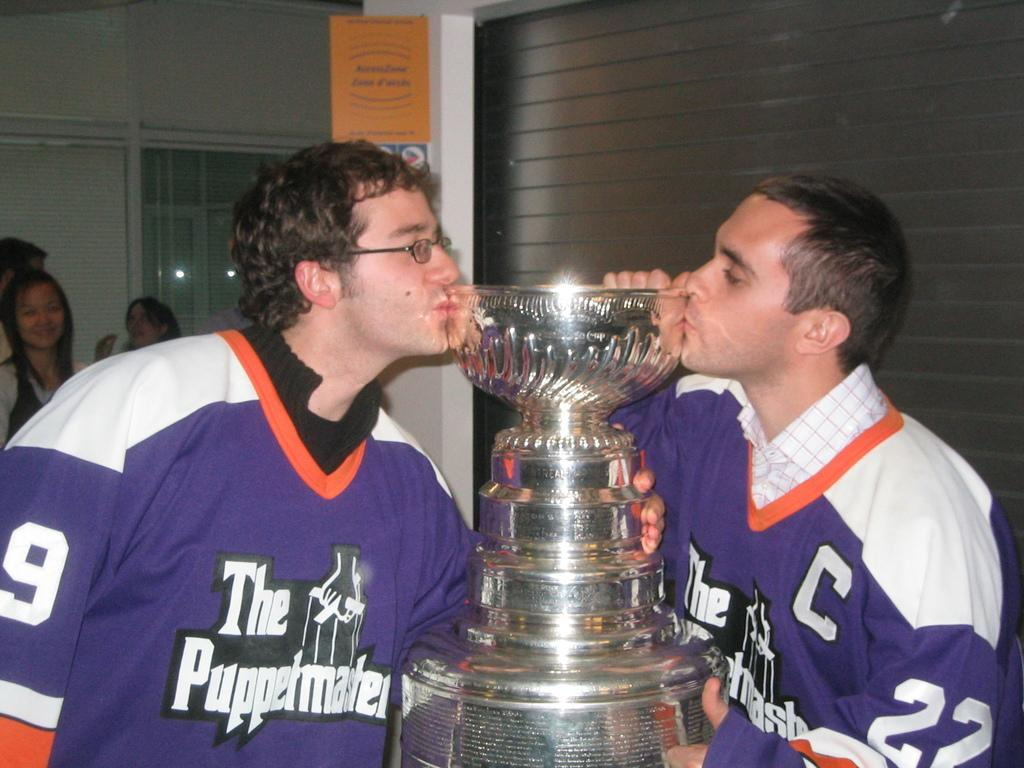<image>
Create a compact narrative representing the image presented. Two men in jerseys for the puppermasters are kissing a trophy. 